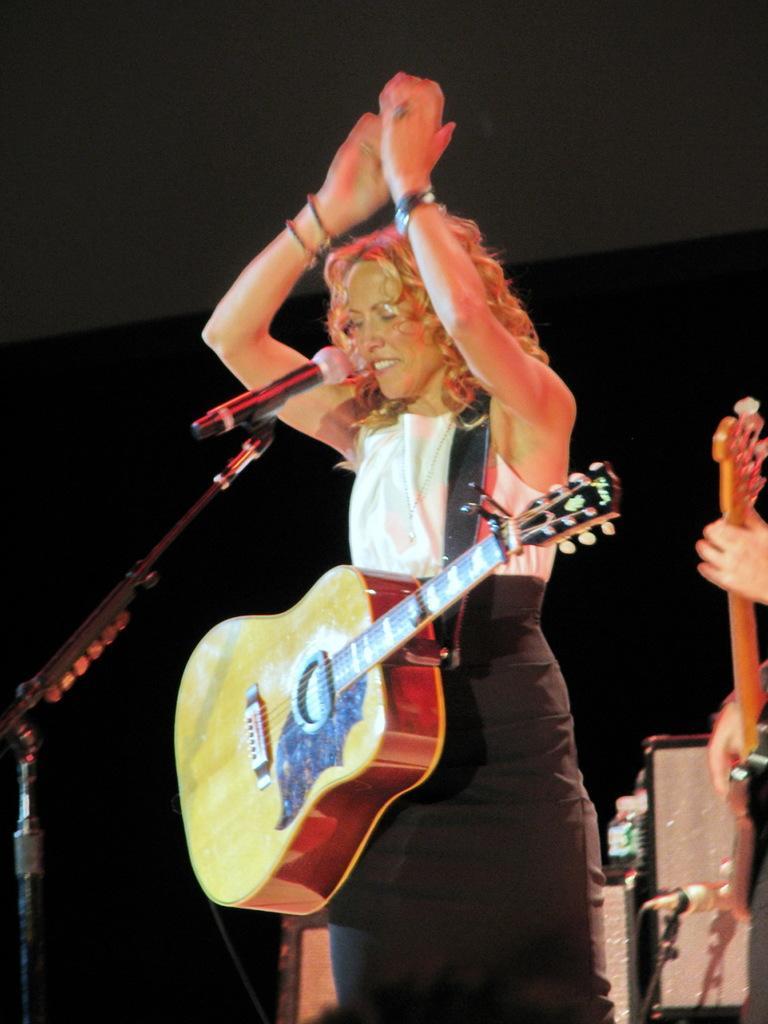How would you summarize this image in a sentence or two? In this picture we can see a woman standing and smiling, and holding a guitar, and in front here is the micro phone and stand. 